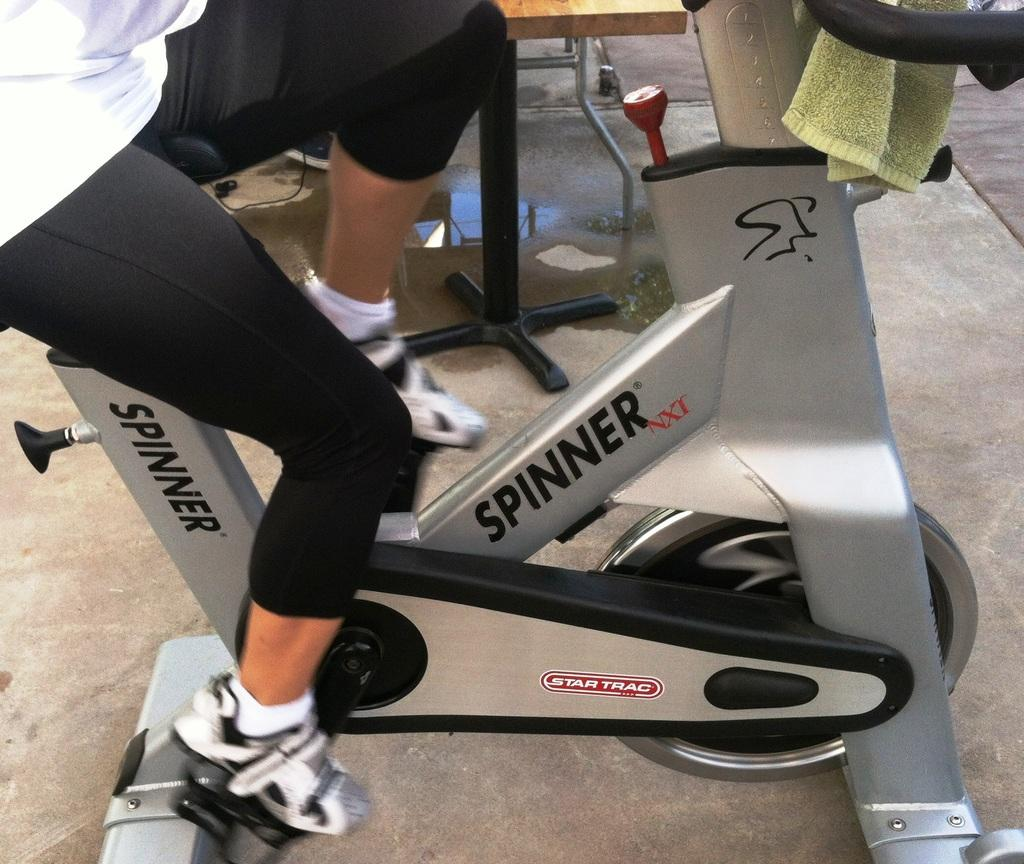What is the main subject of the image? There is a human being in the image. What activity is the human being engaged in? The human being is cycling. What type of equipment is the human being using? The human being is using an exercise machine. What type of screw is visible on the human being's shirt in the image? There is no screw visible on the human being's shirt in the image. What type of shame is the human being experiencing while cycling in the image? There is no indication of shame or any emotional state in the image; the human being is simply cycling. 